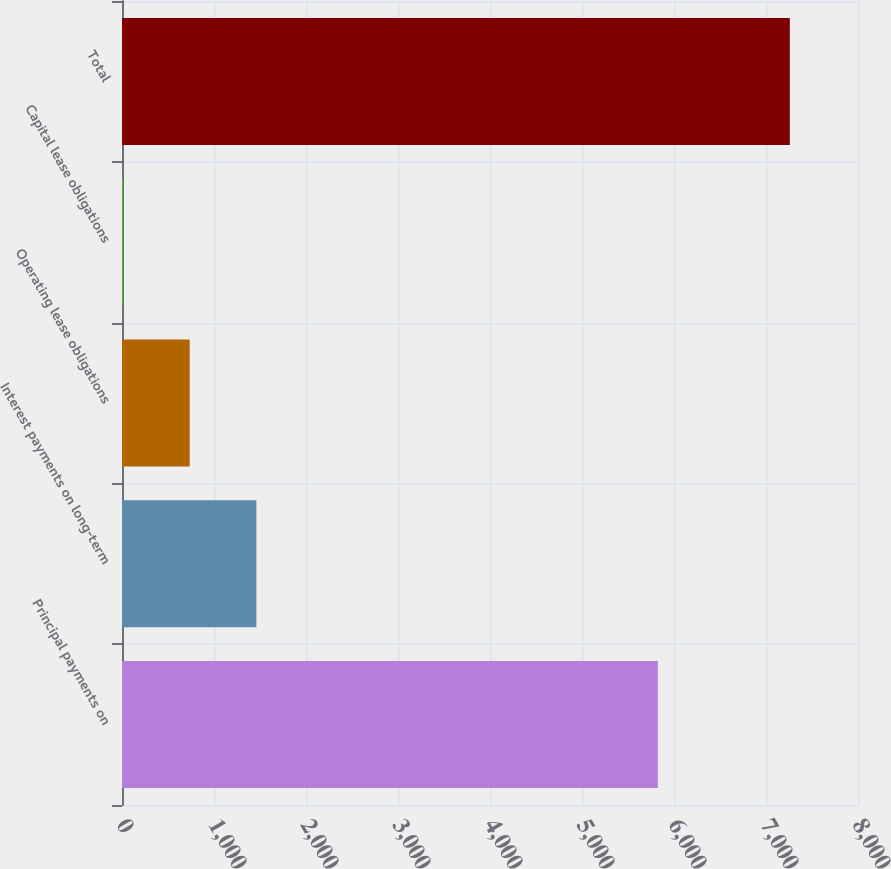Convert chart to OTSL. <chart><loc_0><loc_0><loc_500><loc_500><bar_chart><fcel>Principal payments on<fcel>Interest payments on long-term<fcel>Operating lease obligations<fcel>Capital lease obligations<fcel>Total<nl><fcel>5824<fcel>1460.6<fcel>735.8<fcel>11<fcel>7259<nl></chart> 